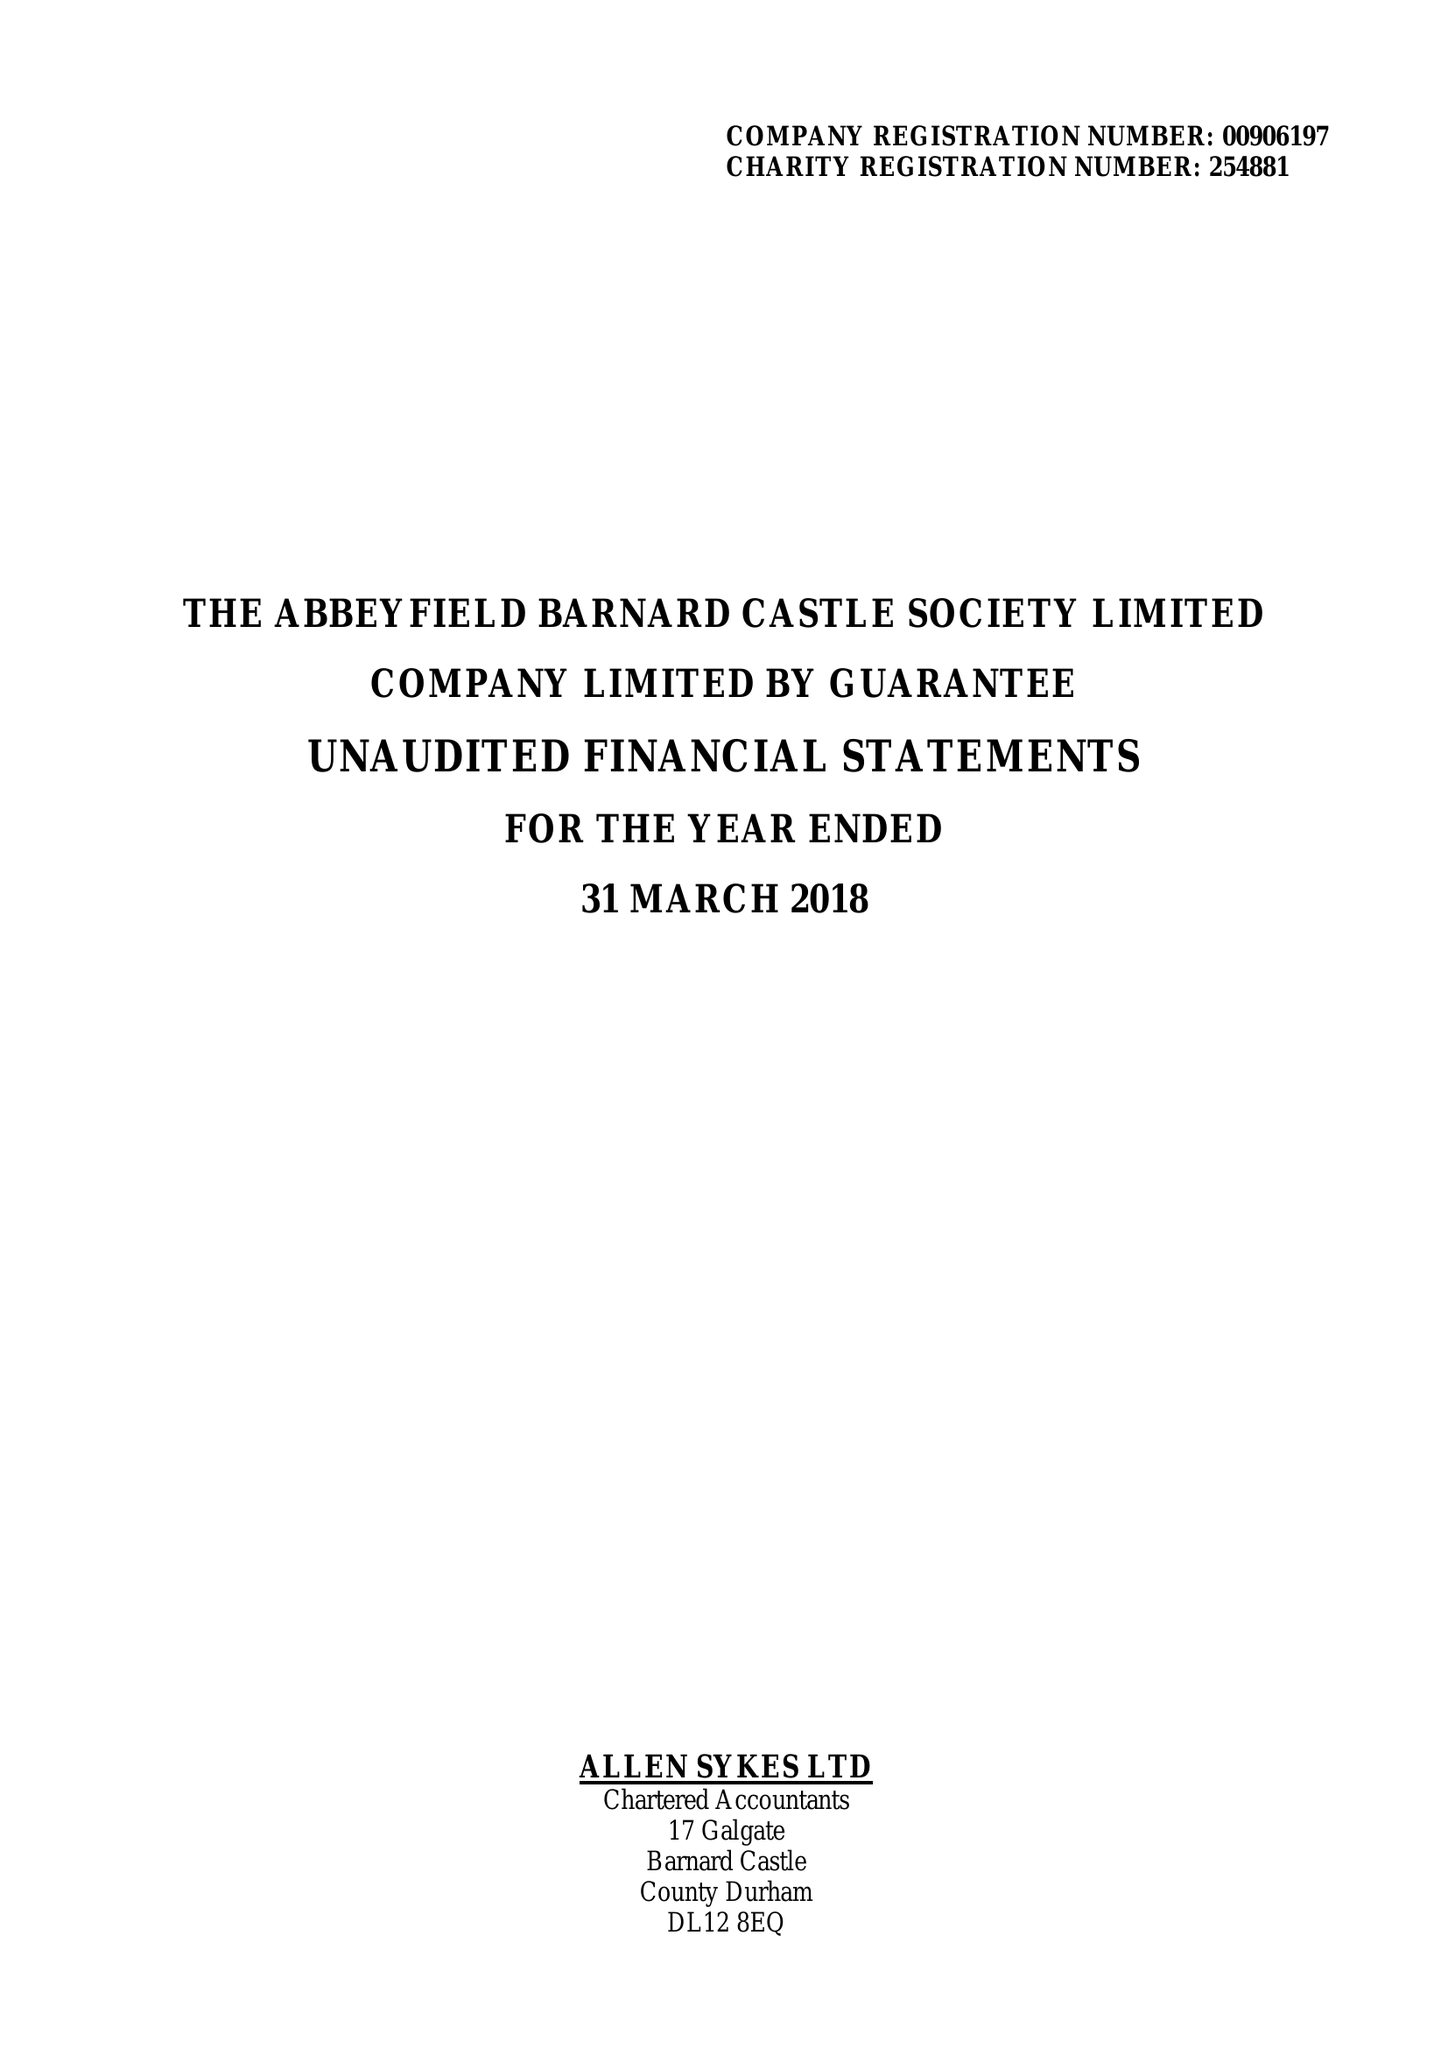What is the value for the charity_number?
Answer the question using a single word or phrase. 254881 